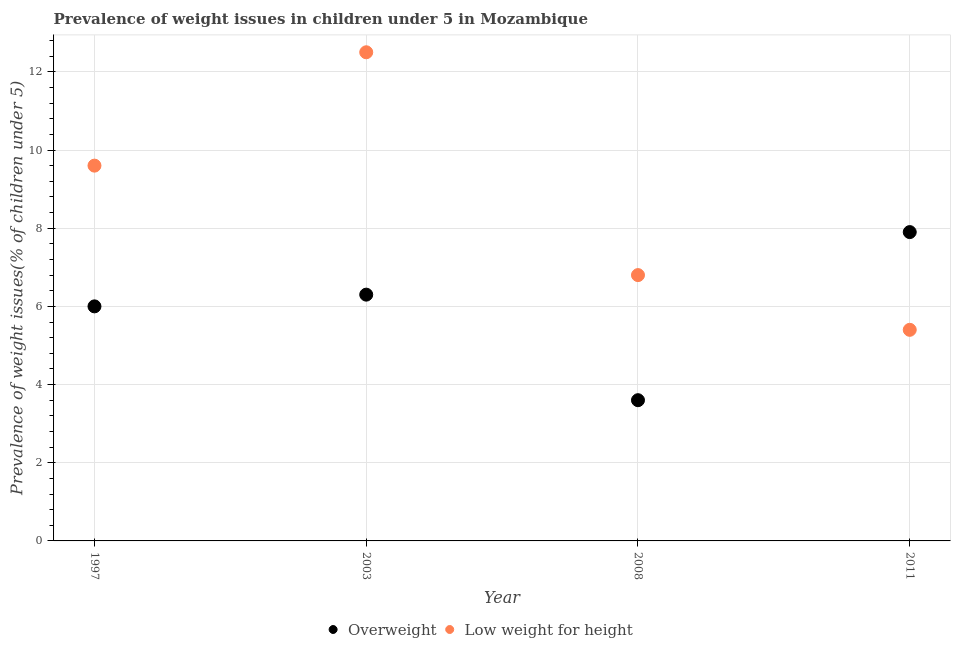Is the number of dotlines equal to the number of legend labels?
Keep it short and to the point. Yes. What is the percentage of underweight children in 2008?
Offer a very short reply. 6.8. Across all years, what is the maximum percentage of overweight children?
Your answer should be very brief. 7.9. Across all years, what is the minimum percentage of overweight children?
Keep it short and to the point. 3.6. In which year was the percentage of overweight children maximum?
Provide a short and direct response. 2011. In which year was the percentage of underweight children minimum?
Your answer should be very brief. 2011. What is the total percentage of underweight children in the graph?
Make the answer very short. 34.3. What is the difference between the percentage of overweight children in 2003 and that in 2011?
Your answer should be very brief. -1.6. What is the difference between the percentage of overweight children in 2011 and the percentage of underweight children in 2003?
Ensure brevity in your answer.  -4.6. What is the average percentage of underweight children per year?
Give a very brief answer. 8.58. In the year 2008, what is the difference between the percentage of underweight children and percentage of overweight children?
Offer a very short reply. 3.2. What is the ratio of the percentage of overweight children in 1997 to that in 2003?
Offer a terse response. 0.95. Is the difference between the percentage of underweight children in 1997 and 2008 greater than the difference between the percentage of overweight children in 1997 and 2008?
Keep it short and to the point. Yes. What is the difference between the highest and the second highest percentage of overweight children?
Keep it short and to the point. 1.6. What is the difference between the highest and the lowest percentage of underweight children?
Your response must be concise. 7.1. Is the percentage of overweight children strictly greater than the percentage of underweight children over the years?
Offer a terse response. No. How many years are there in the graph?
Make the answer very short. 4. Where does the legend appear in the graph?
Offer a terse response. Bottom center. What is the title of the graph?
Your answer should be compact. Prevalence of weight issues in children under 5 in Mozambique. What is the label or title of the X-axis?
Make the answer very short. Year. What is the label or title of the Y-axis?
Keep it short and to the point. Prevalence of weight issues(% of children under 5). What is the Prevalence of weight issues(% of children under 5) in Overweight in 1997?
Provide a succinct answer. 6. What is the Prevalence of weight issues(% of children under 5) of Low weight for height in 1997?
Provide a short and direct response. 9.6. What is the Prevalence of weight issues(% of children under 5) of Overweight in 2003?
Provide a short and direct response. 6.3. What is the Prevalence of weight issues(% of children under 5) in Low weight for height in 2003?
Your response must be concise. 12.5. What is the Prevalence of weight issues(% of children under 5) in Overweight in 2008?
Your answer should be compact. 3.6. What is the Prevalence of weight issues(% of children under 5) in Low weight for height in 2008?
Ensure brevity in your answer.  6.8. What is the Prevalence of weight issues(% of children under 5) of Overweight in 2011?
Provide a succinct answer. 7.9. What is the Prevalence of weight issues(% of children under 5) of Low weight for height in 2011?
Your answer should be compact. 5.4. Across all years, what is the maximum Prevalence of weight issues(% of children under 5) of Overweight?
Provide a short and direct response. 7.9. Across all years, what is the maximum Prevalence of weight issues(% of children under 5) in Low weight for height?
Provide a short and direct response. 12.5. Across all years, what is the minimum Prevalence of weight issues(% of children under 5) in Overweight?
Provide a succinct answer. 3.6. Across all years, what is the minimum Prevalence of weight issues(% of children under 5) in Low weight for height?
Provide a short and direct response. 5.4. What is the total Prevalence of weight issues(% of children under 5) of Overweight in the graph?
Offer a terse response. 23.8. What is the total Prevalence of weight issues(% of children under 5) of Low weight for height in the graph?
Provide a succinct answer. 34.3. What is the difference between the Prevalence of weight issues(% of children under 5) of Overweight in 1997 and that in 2008?
Offer a very short reply. 2.4. What is the difference between the Prevalence of weight issues(% of children under 5) of Overweight in 1997 and that in 2011?
Make the answer very short. -1.9. What is the difference between the Prevalence of weight issues(% of children under 5) in Low weight for height in 1997 and that in 2011?
Ensure brevity in your answer.  4.2. What is the difference between the Prevalence of weight issues(% of children under 5) of Overweight in 2003 and that in 2008?
Provide a succinct answer. 2.7. What is the difference between the Prevalence of weight issues(% of children under 5) in Overweight in 2003 and that in 2011?
Offer a very short reply. -1.6. What is the difference between the Prevalence of weight issues(% of children under 5) of Overweight in 2008 and that in 2011?
Provide a short and direct response. -4.3. What is the difference between the Prevalence of weight issues(% of children under 5) of Overweight in 1997 and the Prevalence of weight issues(% of children under 5) of Low weight for height in 2003?
Your answer should be very brief. -6.5. What is the difference between the Prevalence of weight issues(% of children under 5) of Overweight in 2003 and the Prevalence of weight issues(% of children under 5) of Low weight for height in 2008?
Make the answer very short. -0.5. What is the difference between the Prevalence of weight issues(% of children under 5) of Overweight in 2008 and the Prevalence of weight issues(% of children under 5) of Low weight for height in 2011?
Offer a terse response. -1.8. What is the average Prevalence of weight issues(% of children under 5) of Overweight per year?
Your response must be concise. 5.95. What is the average Prevalence of weight issues(% of children under 5) of Low weight for height per year?
Give a very brief answer. 8.57. In the year 1997, what is the difference between the Prevalence of weight issues(% of children under 5) of Overweight and Prevalence of weight issues(% of children under 5) of Low weight for height?
Offer a terse response. -3.6. In the year 2008, what is the difference between the Prevalence of weight issues(% of children under 5) in Overweight and Prevalence of weight issues(% of children under 5) in Low weight for height?
Offer a very short reply. -3.2. In the year 2011, what is the difference between the Prevalence of weight issues(% of children under 5) in Overweight and Prevalence of weight issues(% of children under 5) in Low weight for height?
Your answer should be compact. 2.5. What is the ratio of the Prevalence of weight issues(% of children under 5) in Overweight in 1997 to that in 2003?
Provide a short and direct response. 0.95. What is the ratio of the Prevalence of weight issues(% of children under 5) in Low weight for height in 1997 to that in 2003?
Ensure brevity in your answer.  0.77. What is the ratio of the Prevalence of weight issues(% of children under 5) in Low weight for height in 1997 to that in 2008?
Provide a short and direct response. 1.41. What is the ratio of the Prevalence of weight issues(% of children under 5) in Overweight in 1997 to that in 2011?
Keep it short and to the point. 0.76. What is the ratio of the Prevalence of weight issues(% of children under 5) in Low weight for height in 1997 to that in 2011?
Provide a succinct answer. 1.78. What is the ratio of the Prevalence of weight issues(% of children under 5) of Low weight for height in 2003 to that in 2008?
Provide a succinct answer. 1.84. What is the ratio of the Prevalence of weight issues(% of children under 5) of Overweight in 2003 to that in 2011?
Make the answer very short. 0.8. What is the ratio of the Prevalence of weight issues(% of children under 5) of Low weight for height in 2003 to that in 2011?
Keep it short and to the point. 2.31. What is the ratio of the Prevalence of weight issues(% of children under 5) in Overweight in 2008 to that in 2011?
Your response must be concise. 0.46. What is the ratio of the Prevalence of weight issues(% of children under 5) in Low weight for height in 2008 to that in 2011?
Offer a very short reply. 1.26. What is the difference between the highest and the second highest Prevalence of weight issues(% of children under 5) in Overweight?
Provide a succinct answer. 1.6. What is the difference between the highest and the lowest Prevalence of weight issues(% of children under 5) in Low weight for height?
Give a very brief answer. 7.1. 